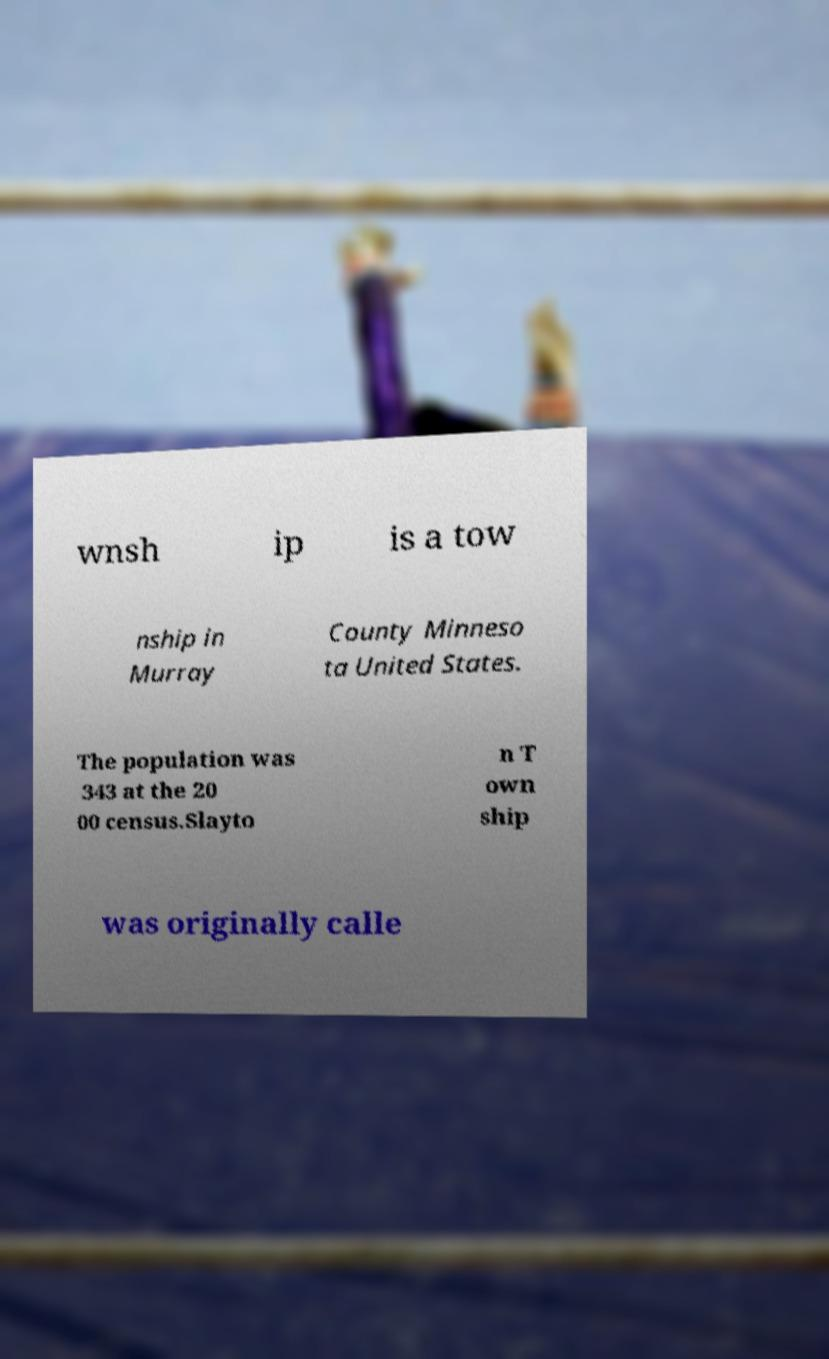There's text embedded in this image that I need extracted. Can you transcribe it verbatim? wnsh ip is a tow nship in Murray County Minneso ta United States. The population was 343 at the 20 00 census.Slayto n T own ship was originally calle 